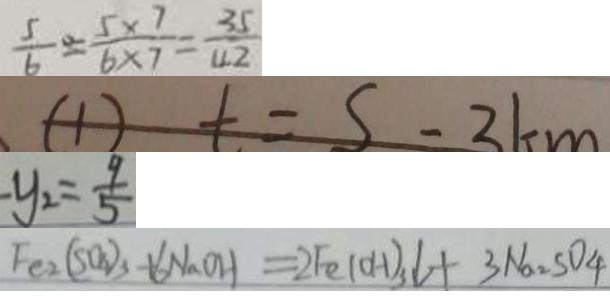Convert formula to latex. <formula><loc_0><loc_0><loc_500><loc_500>\frac { 5 } { 6 } = \frac { 5 \times 7 } { 6 \times 7 } = \frac { 3 5 } { 4 2 } 
 ( 1 ) t = S - 3 k m 
 - y _ { 2 } = \frac { 9 } { 5 } 
 F e _ { 2 } ( S O _ { 4 } ) _ { 3 } + 6 N a O H = 2 F e ( O H ) _ { 3 } \downarrow + 3 N a _ { 2 } S O _ { 4 }</formula> 